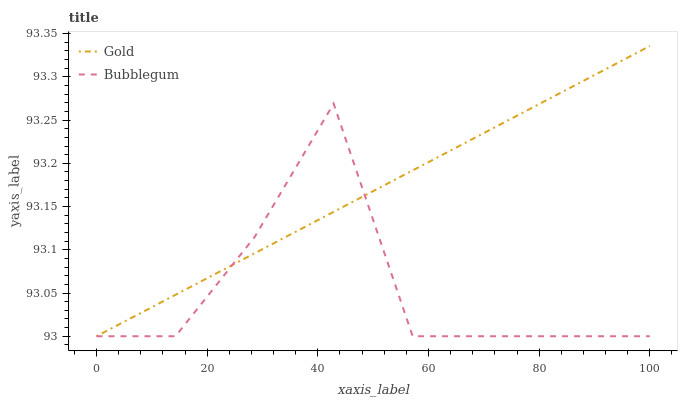Does Bubblegum have the minimum area under the curve?
Answer yes or no. Yes. Does Gold have the maximum area under the curve?
Answer yes or no. Yes. Does Gold have the minimum area under the curve?
Answer yes or no. No. Is Gold the smoothest?
Answer yes or no. Yes. Is Bubblegum the roughest?
Answer yes or no. Yes. Is Gold the roughest?
Answer yes or no. No. Does Bubblegum have the lowest value?
Answer yes or no. Yes. Does Gold have the highest value?
Answer yes or no. Yes. Does Bubblegum intersect Gold?
Answer yes or no. Yes. Is Bubblegum less than Gold?
Answer yes or no. No. Is Bubblegum greater than Gold?
Answer yes or no. No. 